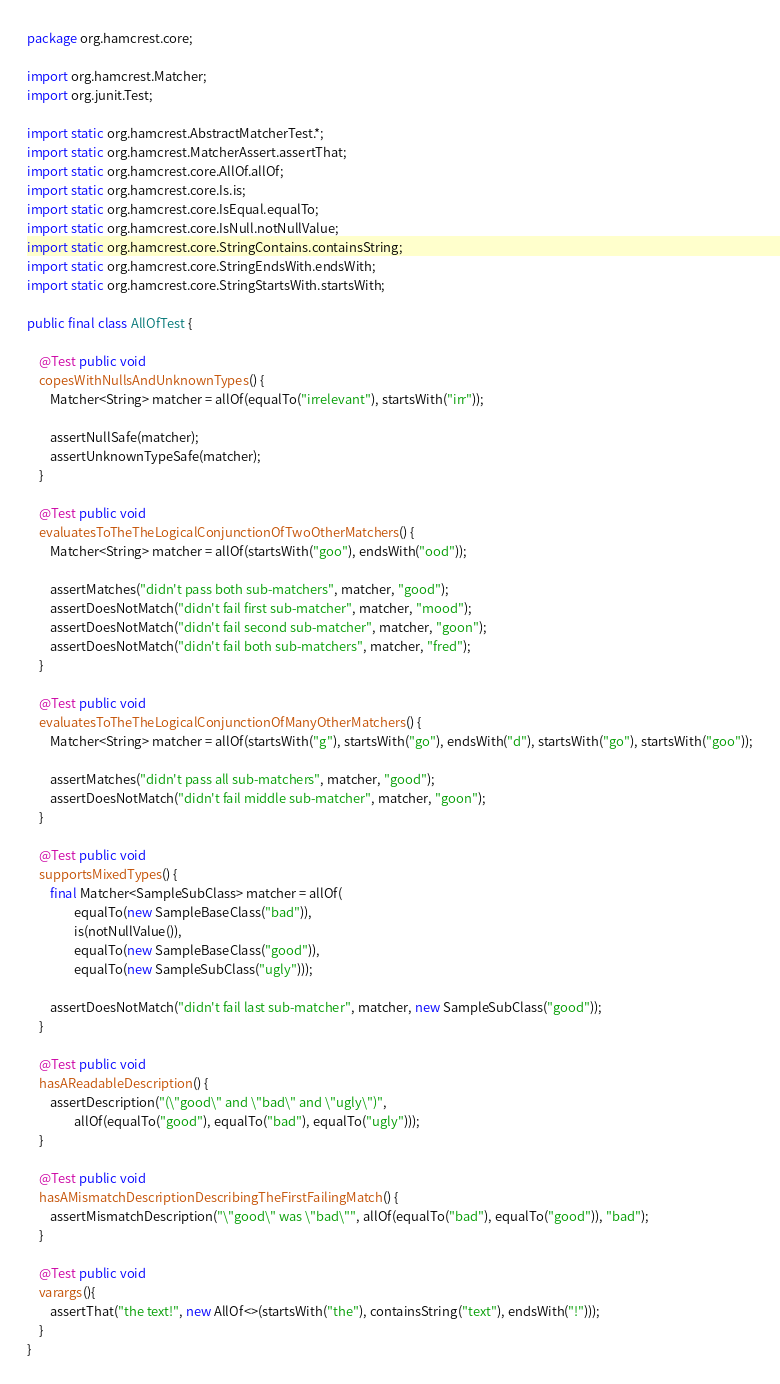<code> <loc_0><loc_0><loc_500><loc_500><_Java_>package org.hamcrest.core;

import org.hamcrest.Matcher;
import org.junit.Test;

import static org.hamcrest.AbstractMatcherTest.*;
import static org.hamcrest.MatcherAssert.assertThat;
import static org.hamcrest.core.AllOf.allOf;
import static org.hamcrest.core.Is.is;
import static org.hamcrest.core.IsEqual.equalTo;
import static org.hamcrest.core.IsNull.notNullValue;
import static org.hamcrest.core.StringContains.containsString;
import static org.hamcrest.core.StringEndsWith.endsWith;
import static org.hamcrest.core.StringStartsWith.startsWith;

public final class AllOfTest {

    @Test public void
    copesWithNullsAndUnknownTypes() {
        Matcher<String> matcher = allOf(equalTo("irrelevant"), startsWith("irr"));
        
        assertNullSafe(matcher);
        assertUnknownTypeSafe(matcher);
    }
    
    @Test public void
    evaluatesToTheTheLogicalConjunctionOfTwoOtherMatchers() {
        Matcher<String> matcher = allOf(startsWith("goo"), endsWith("ood"));
        
        assertMatches("didn't pass both sub-matchers", matcher, "good");
        assertDoesNotMatch("didn't fail first sub-matcher", matcher, "mood");
        assertDoesNotMatch("didn't fail second sub-matcher", matcher, "goon");
        assertDoesNotMatch("didn't fail both sub-matchers", matcher, "fred");
    }

    @Test public void
    evaluatesToTheTheLogicalConjunctionOfManyOtherMatchers() {
        Matcher<String> matcher = allOf(startsWith("g"), startsWith("go"), endsWith("d"), startsWith("go"), startsWith("goo"));
        
        assertMatches("didn't pass all sub-matchers", matcher, "good");
        assertDoesNotMatch("didn't fail middle sub-matcher", matcher, "goon");
    }
    
    @Test public void
    supportsMixedTypes() {
        final Matcher<SampleSubClass> matcher = allOf(
                equalTo(new SampleBaseClass("bad")),
                is(notNullValue()),
                equalTo(new SampleBaseClass("good")),
                equalTo(new SampleSubClass("ugly")));
        
        assertDoesNotMatch("didn't fail last sub-matcher", matcher, new SampleSubClass("good"));
    }
    
    @Test public void
    hasAReadableDescription() {
        assertDescription("(\"good\" and \"bad\" and \"ugly\")",
                allOf(equalTo("good"), equalTo("bad"), equalTo("ugly")));
    }

    @Test public void
    hasAMismatchDescriptionDescribingTheFirstFailingMatch() {
        assertMismatchDescription("\"good\" was \"bad\"", allOf(equalTo("bad"), equalTo("good")), "bad");
    }

    @Test public void
    varargs(){
        assertThat("the text!", new AllOf<>(startsWith("the"), containsString("text"), endsWith("!")));
    }
}
</code> 